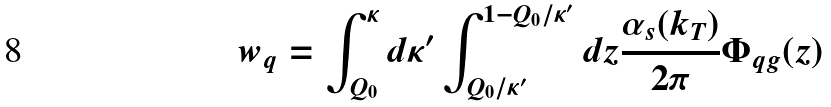Convert formula to latex. <formula><loc_0><loc_0><loc_500><loc_500>w _ { q } = \int _ { Q _ { 0 } } ^ { \kappa } d \kappa ^ { \prime } \int _ { Q _ { 0 } / \kappa ^ { \prime } } ^ { 1 - Q _ { 0 } / \kappa ^ { \prime } } d z \frac { \alpha _ { s } ( k _ { T } ) } { 2 \pi } \Phi _ { q g } ( z )</formula> 